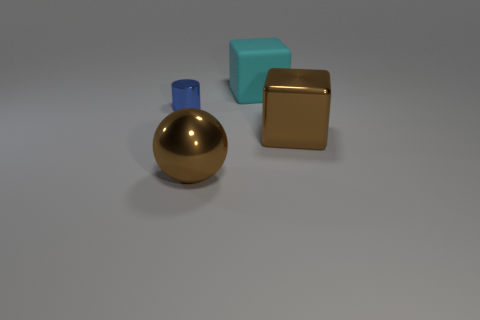Do the thing left of the brown shiny sphere and the object behind the metal cylinder have the same material?
Offer a very short reply. No. Are there fewer small blue metal objects that are behind the shiny sphere than small metallic things?
Ensure brevity in your answer.  No. The large metal thing on the left side of the cyan matte thing is what color?
Offer a terse response. Brown. What is the big object that is behind the big brown shiny object behind the large ball made of?
Give a very brief answer. Rubber. Is there a green metallic cube that has the same size as the blue metal thing?
Provide a succinct answer. No. What number of things are large blocks that are in front of the large cyan rubber block or metal things to the right of the large brown sphere?
Ensure brevity in your answer.  1. There is a thing that is on the left side of the big sphere; does it have the same size as the brown metallic object to the right of the large brown shiny ball?
Provide a short and direct response. No. Are there any big cyan cubes on the left side of the metallic object that is to the right of the large brown shiny ball?
Ensure brevity in your answer.  Yes. There is a big cyan rubber cube; what number of tiny blue metallic objects are behind it?
Make the answer very short. 0. How many other objects are the same color as the big rubber cube?
Ensure brevity in your answer.  0. 